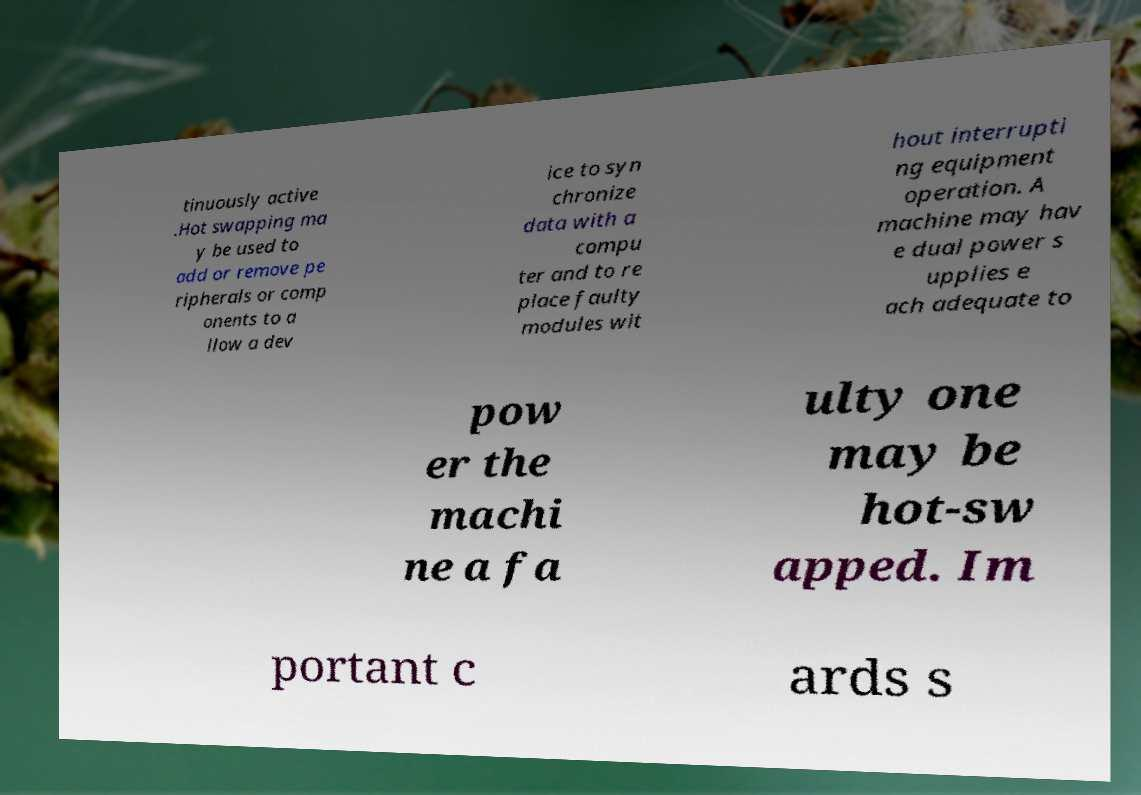Please identify and transcribe the text found in this image. tinuously active .Hot swapping ma y be used to add or remove pe ripherals or comp onents to a llow a dev ice to syn chronize data with a compu ter and to re place faulty modules wit hout interrupti ng equipment operation. A machine may hav e dual power s upplies e ach adequate to pow er the machi ne a fa ulty one may be hot-sw apped. Im portant c ards s 